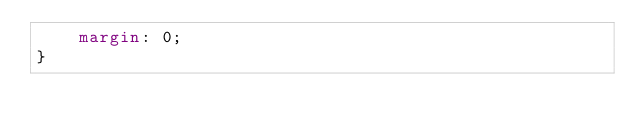<code> <loc_0><loc_0><loc_500><loc_500><_CSS_>    margin: 0;
}</code> 